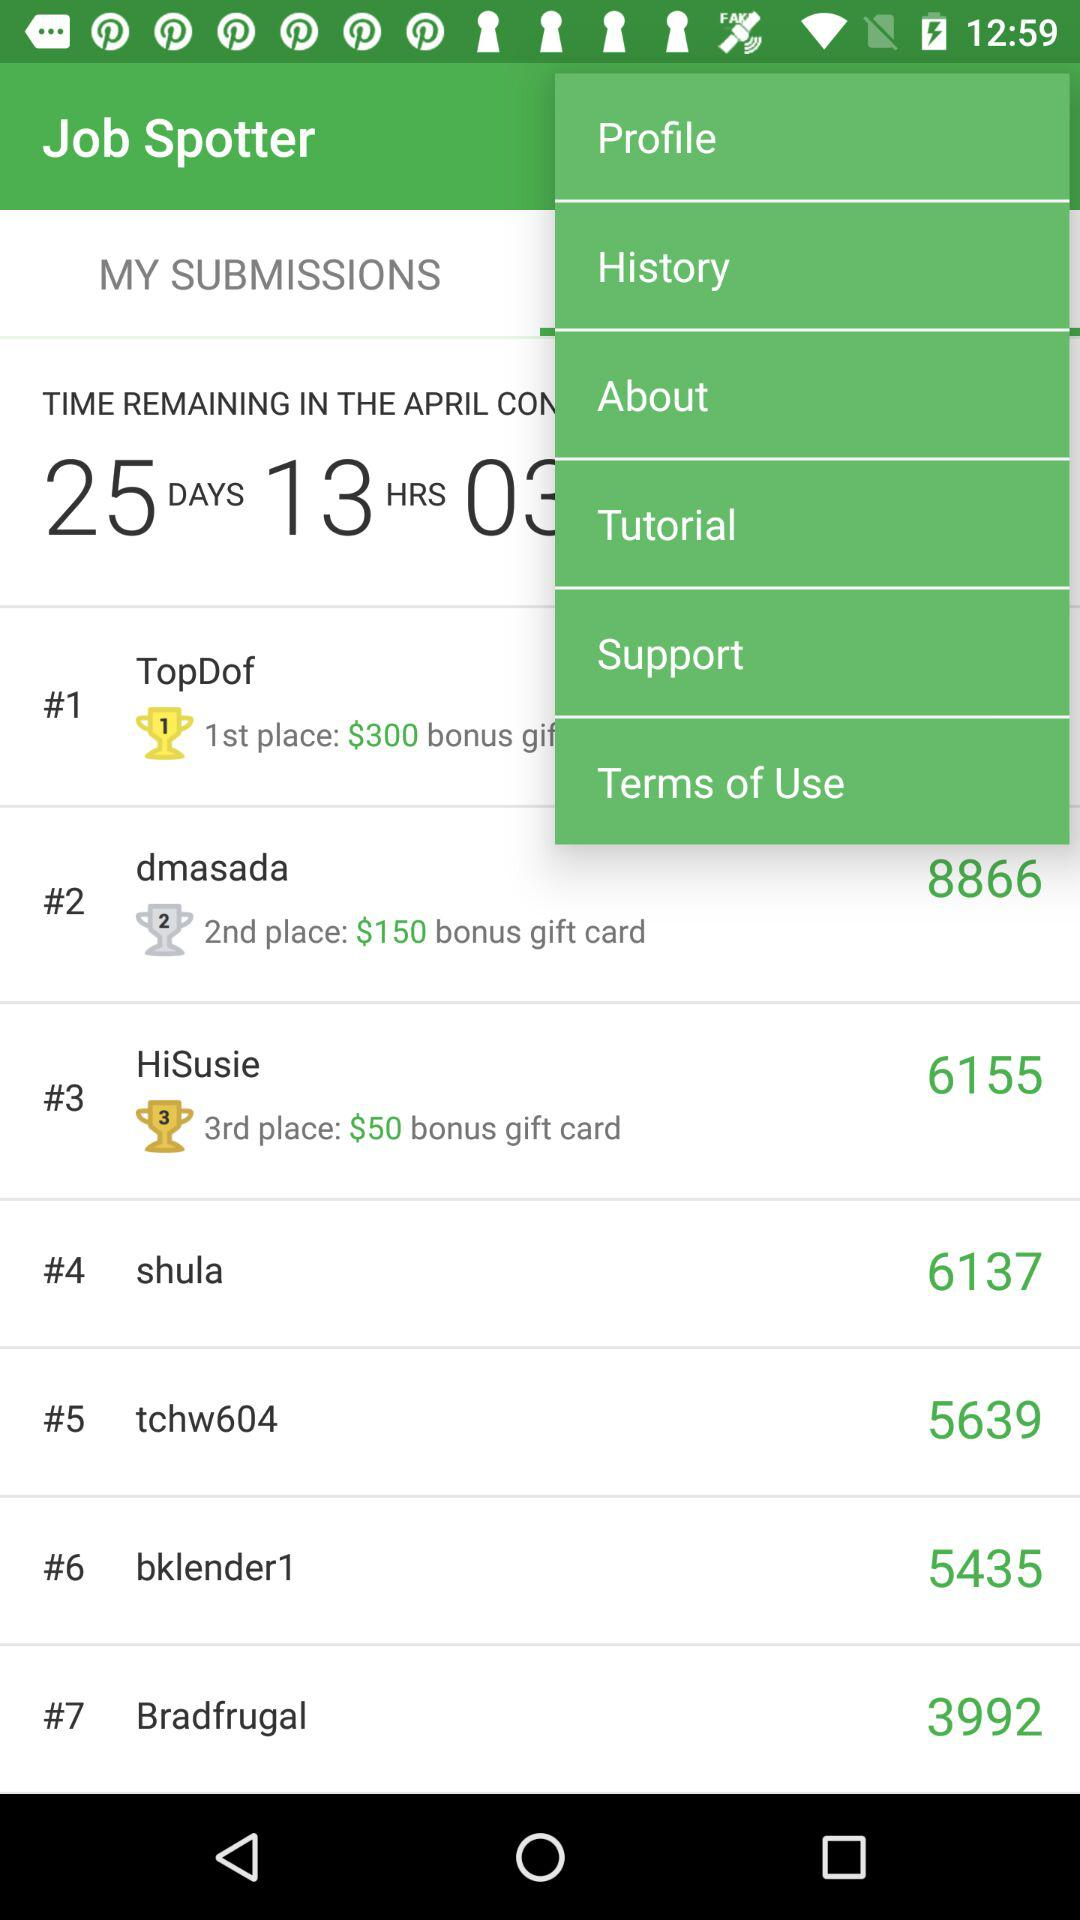How many places are there in the leaderboard?
Answer the question using a single word or phrase. 7 